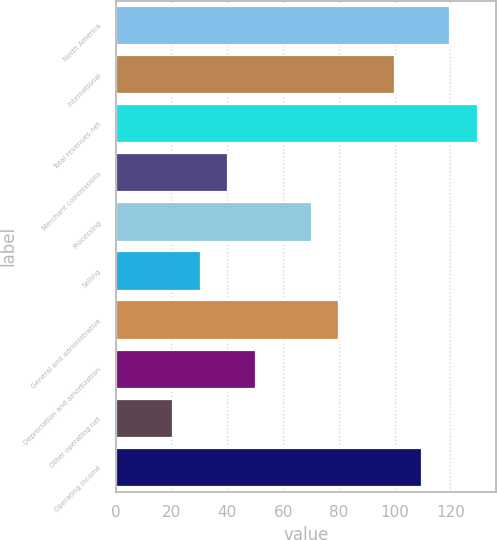Convert chart. <chart><loc_0><loc_0><loc_500><loc_500><bar_chart><fcel>North America<fcel>International<fcel>Total revenues net<fcel>Merchant commissions<fcel>Processing<fcel>Selling<fcel>General and administrative<fcel>Depreciation and amortization<fcel>Other operating net<fcel>Operating income<nl><fcel>119.86<fcel>100<fcel>129.79<fcel>40.42<fcel>70.21<fcel>30.49<fcel>80.14<fcel>50.35<fcel>20.56<fcel>109.93<nl></chart> 